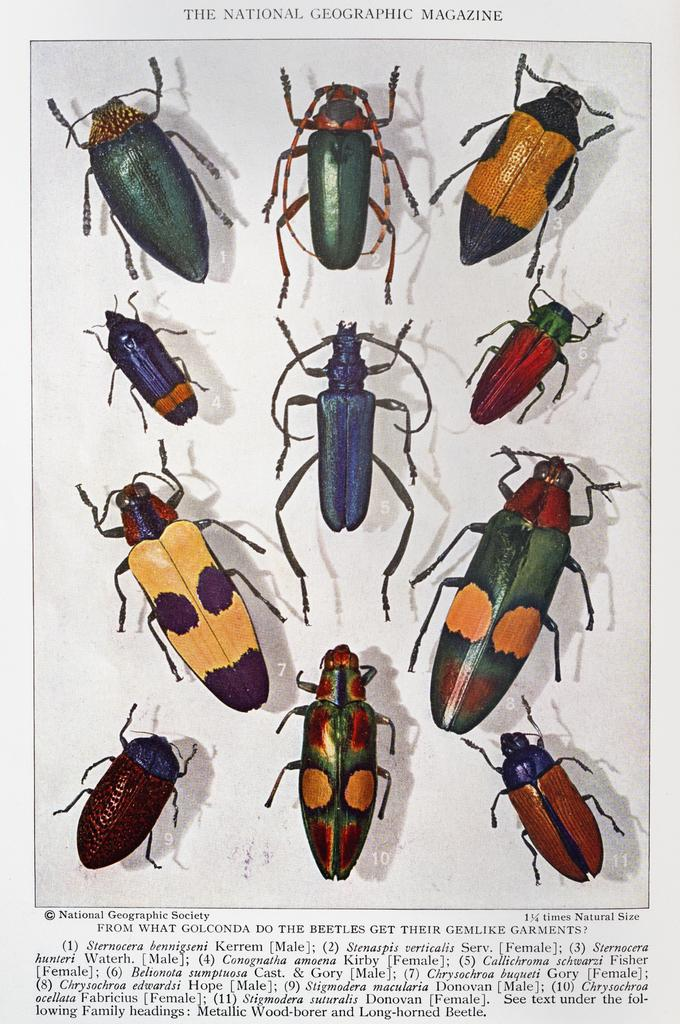What is the main subject of the image? The main subject of the image is a magazine. What type of content is featured in the magazine? The magazine contains pictures of insects. Where can text be found in the image? There is text at the top and bottom of the image. Are there any numbers present in the image? Yes, there are numerical numbers in the image. How many cats are walking on the sidewalk in the image? There are no cats or sidewalks present in the image; it features a magazine with pictures of insects and text. What type of rose is depicted in the image? There is no rose present in the image; it features a magazine with pictures of insects and text. 